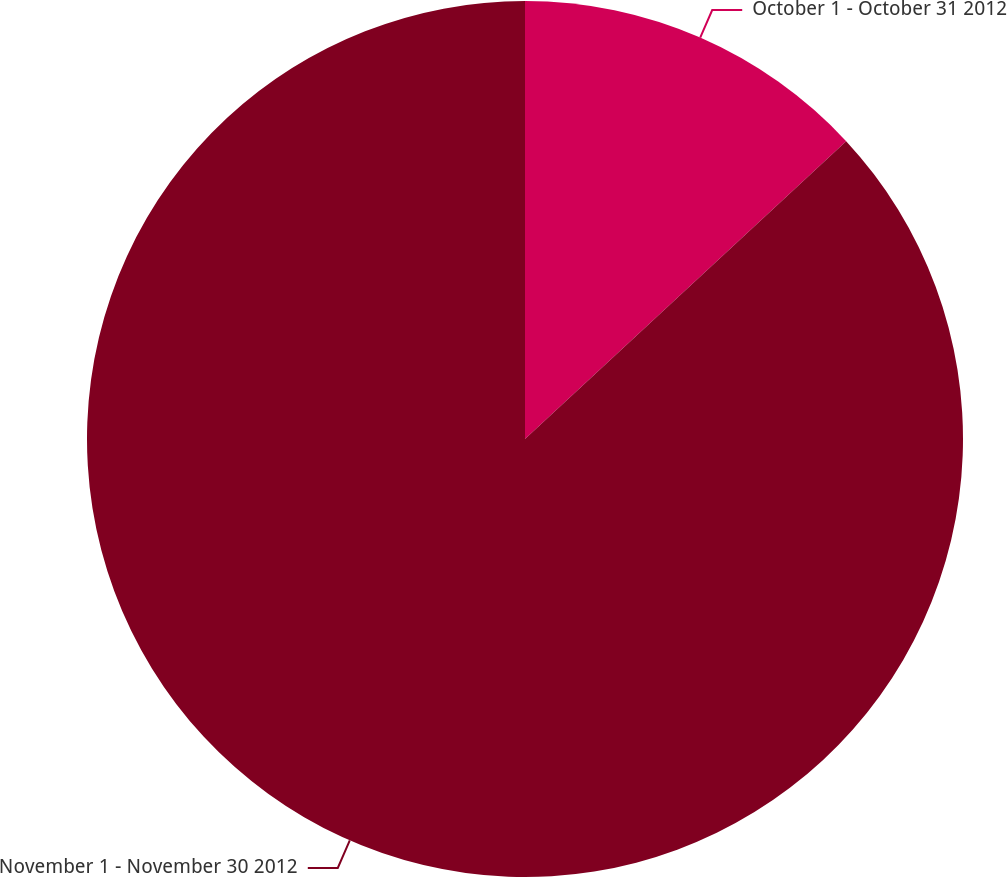Convert chart to OTSL. <chart><loc_0><loc_0><loc_500><loc_500><pie_chart><fcel>October 1 - October 31 2012<fcel>November 1 - November 30 2012<nl><fcel>13.1%<fcel>86.9%<nl></chart> 